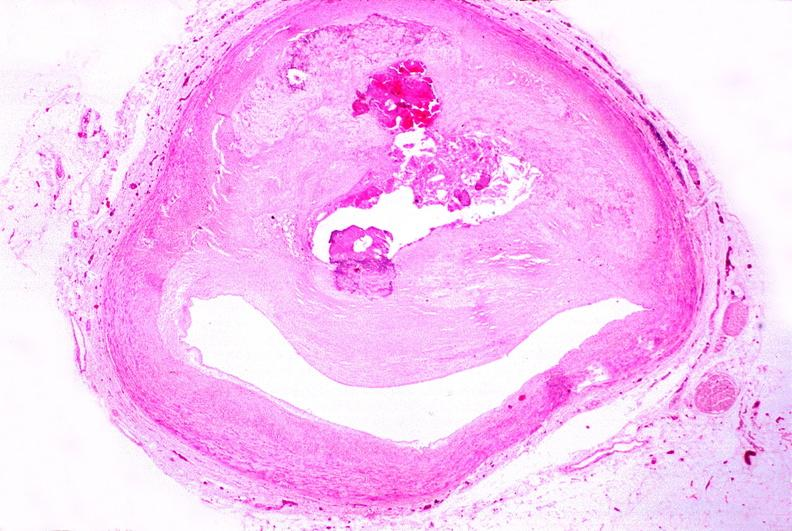s cardiovascular present?
Answer the question using a single word or phrase. Yes 